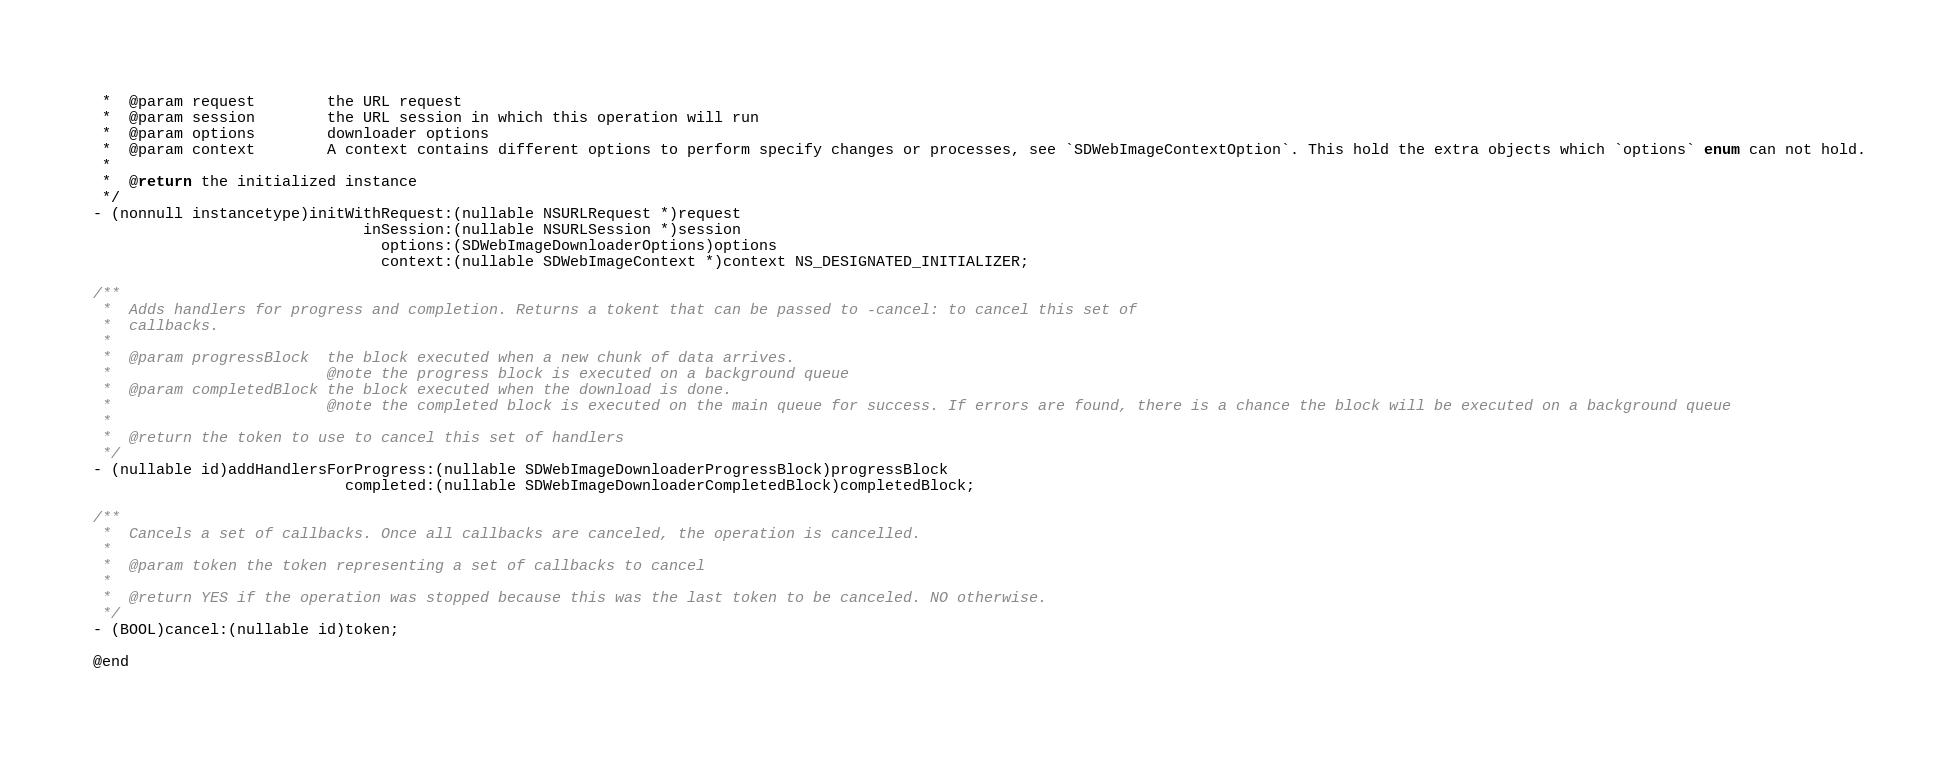Convert code to text. <code><loc_0><loc_0><loc_500><loc_500><_C_> *  @param request        the URL request
 *  @param session        the URL session in which this operation will run
 *  @param options        downloader options
 *  @param context        A context contains different options to perform specify changes or processes, see `SDWebImageContextOption`. This hold the extra objects which `options` enum can not hold.
 *
 *  @return the initialized instance
 */
- (nonnull instancetype)initWithRequest:(nullable NSURLRequest *)request
                              inSession:(nullable NSURLSession *)session
                                options:(SDWebImageDownloaderOptions)options
                                context:(nullable SDWebImageContext *)context NS_DESIGNATED_INITIALIZER;

/**
 *  Adds handlers for progress and completion. Returns a tokent that can be passed to -cancel: to cancel this set of
 *  callbacks.
 *
 *  @param progressBlock  the block executed when a new chunk of data arrives.
 *                        @note the progress block is executed on a background queue
 *  @param completedBlock the block executed when the download is done.
 *                        @note the completed block is executed on the main queue for success. If errors are found, there is a chance the block will be executed on a background queue
 *
 *  @return the token to use to cancel this set of handlers
 */
- (nullable id)addHandlersForProgress:(nullable SDWebImageDownloaderProgressBlock)progressBlock
                            completed:(nullable SDWebImageDownloaderCompletedBlock)completedBlock;

/**
 *  Cancels a set of callbacks. Once all callbacks are canceled, the operation is cancelled.
 *
 *  @param token the token representing a set of callbacks to cancel
 *
 *  @return YES if the operation was stopped because this was the last token to be canceled. NO otherwise.
 */
- (BOOL)cancel:(nullable id)token;

@end
</code> 